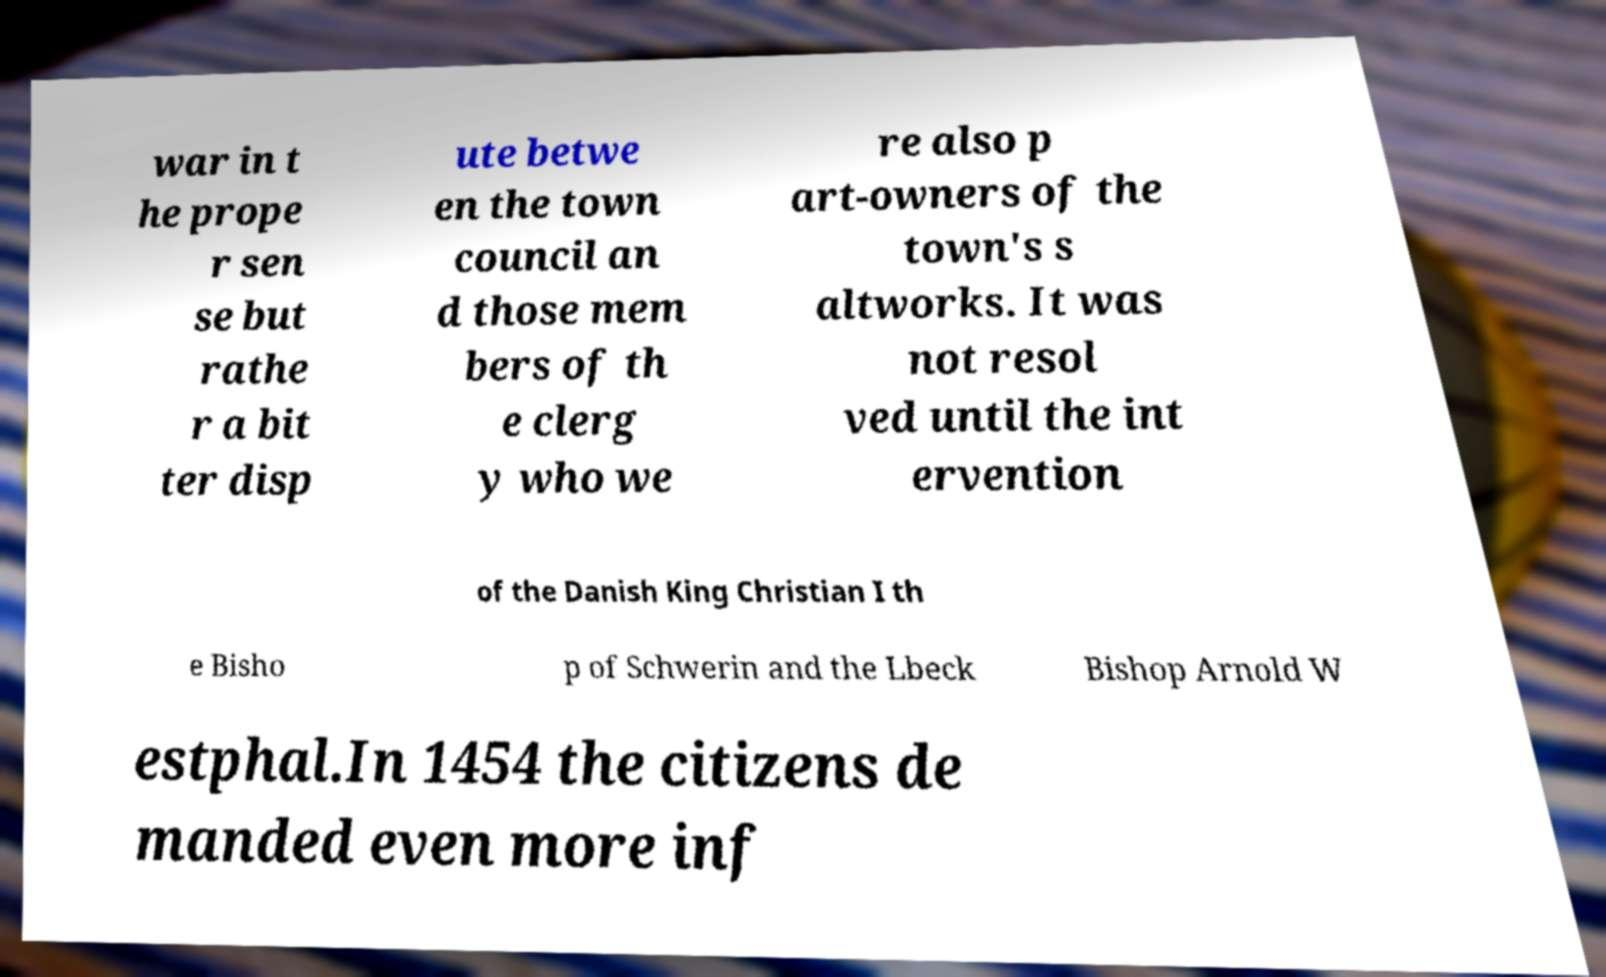Could you extract and type out the text from this image? war in t he prope r sen se but rathe r a bit ter disp ute betwe en the town council an d those mem bers of th e clerg y who we re also p art-owners of the town's s altworks. It was not resol ved until the int ervention of the Danish King Christian I th e Bisho p of Schwerin and the Lbeck Bishop Arnold W estphal.In 1454 the citizens de manded even more inf 